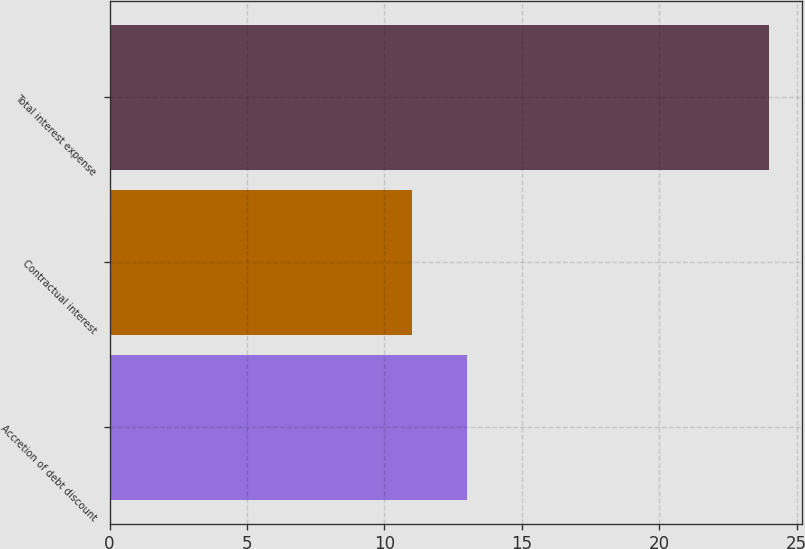Convert chart. <chart><loc_0><loc_0><loc_500><loc_500><bar_chart><fcel>Accretion of debt discount<fcel>Contractual interest<fcel>Total interest expense<nl><fcel>13<fcel>11<fcel>24<nl></chart> 